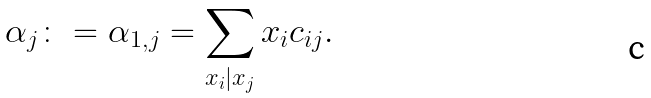Convert formula to latex. <formula><loc_0><loc_0><loc_500><loc_500>\alpha _ { j } \colon = \alpha _ { 1 , j } = \sum _ { x _ { i } | x _ { j } } x _ { i } c _ { i j } .</formula> 